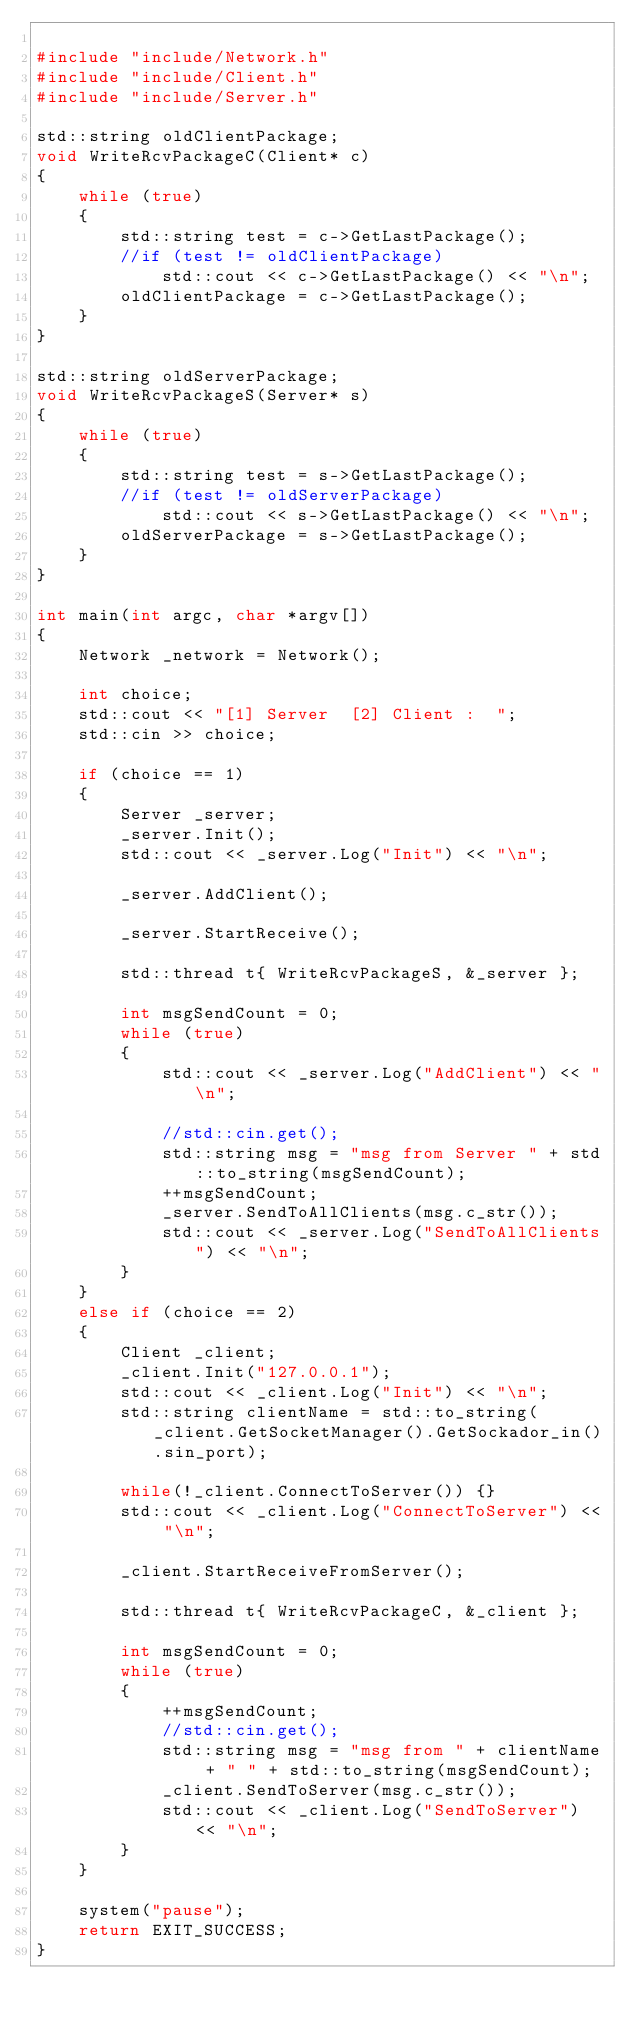Convert code to text. <code><loc_0><loc_0><loc_500><loc_500><_C++_>
#include "include/Network.h"
#include "include/Client.h"
#include "include/Server.h"

std::string oldClientPackage;
void WriteRcvPackageC(Client* c)
{
	while (true)
	{
		std::string test = c->GetLastPackage();
		//if (test != oldClientPackage)
			std::cout << c->GetLastPackage() << "\n";
		oldClientPackage = c->GetLastPackage();
	}
}

std::string oldServerPackage;
void WriteRcvPackageS(Server* s)
{
	while (true)
	{
		std::string test = s->GetLastPackage();
		//if (test != oldServerPackage)
			std::cout << s->GetLastPackage() << "\n";
		oldServerPackage = s->GetLastPackage();
	}
}

int main(int argc, char *argv[])
{
	Network _network = Network();

	int choice;
	std::cout << "[1] Server  [2] Client :  ";
	std::cin >> choice;

	if (choice == 1)
	{
		Server _server;
		_server.Init();
		std::cout << _server.Log("Init") << "\n";

		_server.AddClient();

		_server.StartReceive();

		std::thread t{ WriteRcvPackageS, &_server };

		int	msgSendCount = 0;
		while (true)
		{
			std::cout << _server.Log("AddClient") << "\n";

			//std::cin.get();
			std::string msg = "msg from Server " + std::to_string(msgSendCount);
			++msgSendCount;
			_server.SendToAllClients(msg.c_str());
			std::cout << _server.Log("SendToAllClients") << "\n";
		}
	}
	else if (choice == 2)
	{
		Client _client;
		_client.Init("127.0.0.1");
		std::cout << _client.Log("Init") << "\n";
		std::string clientName = std::to_string(_client.GetSocketManager().GetSockador_in().sin_port);

		while(!_client.ConnectToServer()) {}
		std::cout << _client.Log("ConnectToServer") << "\n";

		_client.StartReceiveFromServer();

		std::thread t{ WriteRcvPackageC, &_client };

		int msgSendCount = 0;
		while (true)
		{
			++msgSendCount;
			//std::cin.get();
			std::string msg = "msg from " + clientName + " " + std::to_string(msgSendCount);
			_client.SendToServer(msg.c_str());
			std::cout << _client.Log("SendToServer") << "\n";
		}
	}

	system("pause");
	return EXIT_SUCCESS;
}
</code> 